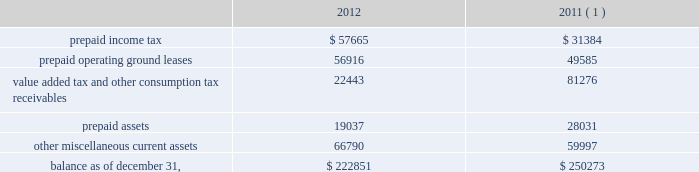American tower corporation and subsidiaries notes to consolidated financial statements loss on retirement of long-term obligations 2014loss on retirement of long-term obligations primarily includes cash paid to retire debt in excess of its carrying value , cash paid to holders of convertible notes in connection with note conversions and non-cash charges related to the write-off of deferred financing fees .
Loss on retirement of long-term obligations also includes gains from repurchasing or refinancing certain of the company 2019s debt obligations .
Earnings per common share 2014basic and diluted 2014basic income from continuing operations per common share for the years ended december 31 , 2012 , 2011 and 2010 represents income from continuing operations attributable to american tower corporation divided by the weighted average number of common shares outstanding during the period .
Diluted income from continuing operations per common share for the years ended december 31 , 2012 , 2011 and 2010 represents income from continuing operations attributable to american tower corporation divided by the weighted average number of common shares outstanding during the period and any dilutive common share equivalents , including unvested restricted stock , shares issuable upon exercise of stock options and warrants as determined under the treasury stock method and upon conversion of the company 2019s convertible notes , as determined under the if-converted method .
Retirement plan 2014the company has a 401 ( k ) plan covering substantially all employees who meet certain age and employment requirements .
The company 2019s matching contribution for the years ended december 31 , 2012 , 2011 and 2010 is 50% ( 50 % ) up to a maximum 6% ( 6 % ) of a participant 2019s contributions .
For the years ended december 31 , 2012 , 2011 and 2010 , the company contributed approximately $ 4.4 million , $ 2.9 million and $ 1.9 million to the plan , respectively .
Prepaid and other current assets prepaid and other current assets consist of the following as of december 31 , ( in thousands ) : .
( 1 ) december 31 , 2011 balances have been revised to reflect purchase accounting measurement period adjustments. .
For 2012 , tax related assets were how much of total current assets and prepaids?\\n\\n? 
Computations: ((57665 + 22443) / 222851)
Answer: 0.35947. 